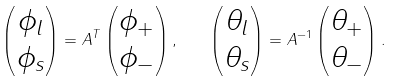Convert formula to latex. <formula><loc_0><loc_0><loc_500><loc_500>\begin{pmatrix} \phi _ { l } \\ \phi _ { s } \end{pmatrix} = A ^ { T } \begin{pmatrix} \phi _ { + } \\ \phi _ { - } \end{pmatrix} , \quad \begin{pmatrix} \theta _ { l } \\ \theta _ { s } \end{pmatrix} = A ^ { - 1 } \begin{pmatrix} \theta _ { + } \\ \theta _ { - } \end{pmatrix} .</formula> 